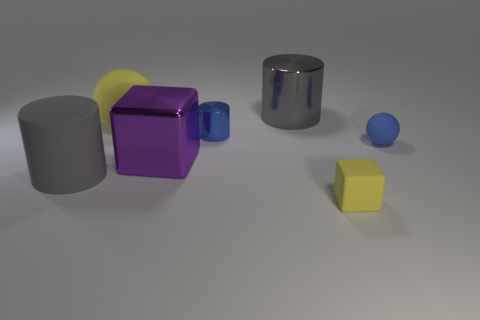Can you describe the lighting and shadows in the scene? The lighting in the image comes from the upper left, creating soft shadows that trail off to the lower right of the objects. The shadows help define the form of each object, indicating a single, diffused light source. Interestingly, the smooth surfaces, especially on the metallic cylinders, reflect some of the light, giving a clue about the environment around them. 